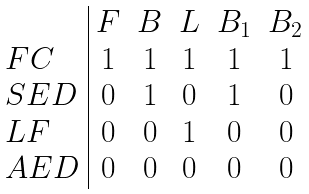Convert formula to latex. <formula><loc_0><loc_0><loc_500><loc_500>\begin{array} { l | c c c c c } & F & B & L & B _ { 1 } & B _ { 2 } \\ F C & 1 & 1 & 1 & 1 & 1 \\ S E D & 0 & 1 & 0 & 1 & 0 \\ L F & 0 & 0 & 1 & 0 & 0 \\ A E D & 0 & 0 & 0 & 0 & 0 \end{array}</formula> 